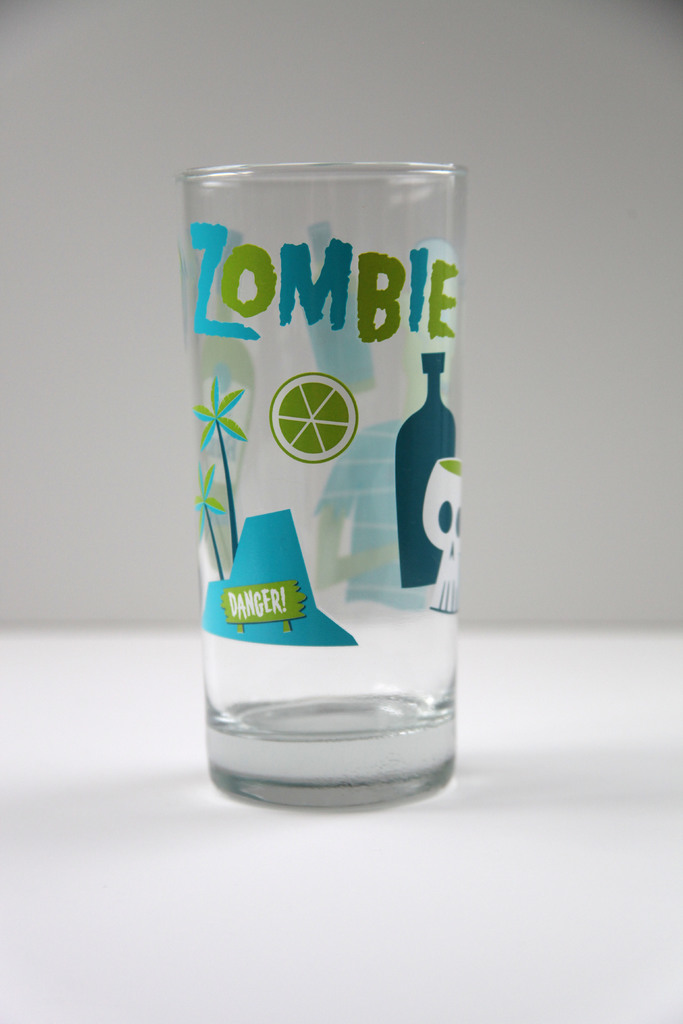What could be the thematic significance of the elements displayed on the glass? The thematic elements on the glass, such as the skull, tropical imagery, and the word 'ZOMBIE', are likely inspired by Tiki culture and the concept of exotic cocktails, often linked with themes of danger and adventure in tropical settings. 